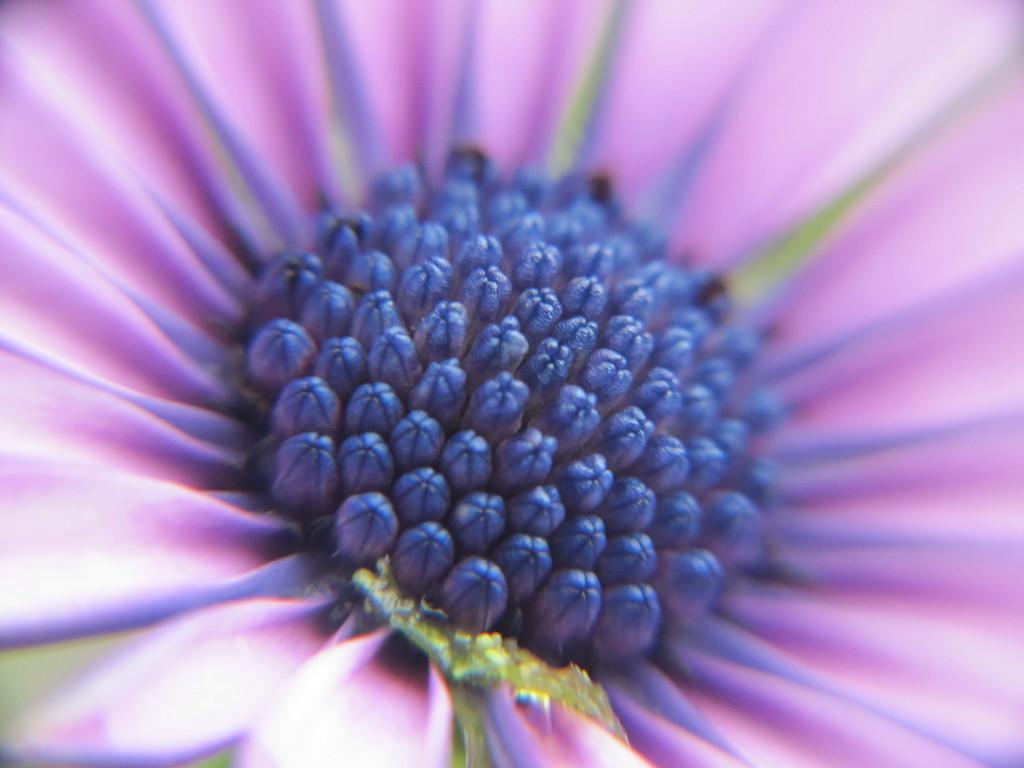Describe this image in one or two sentences. The picture consists of a violet color flower. 